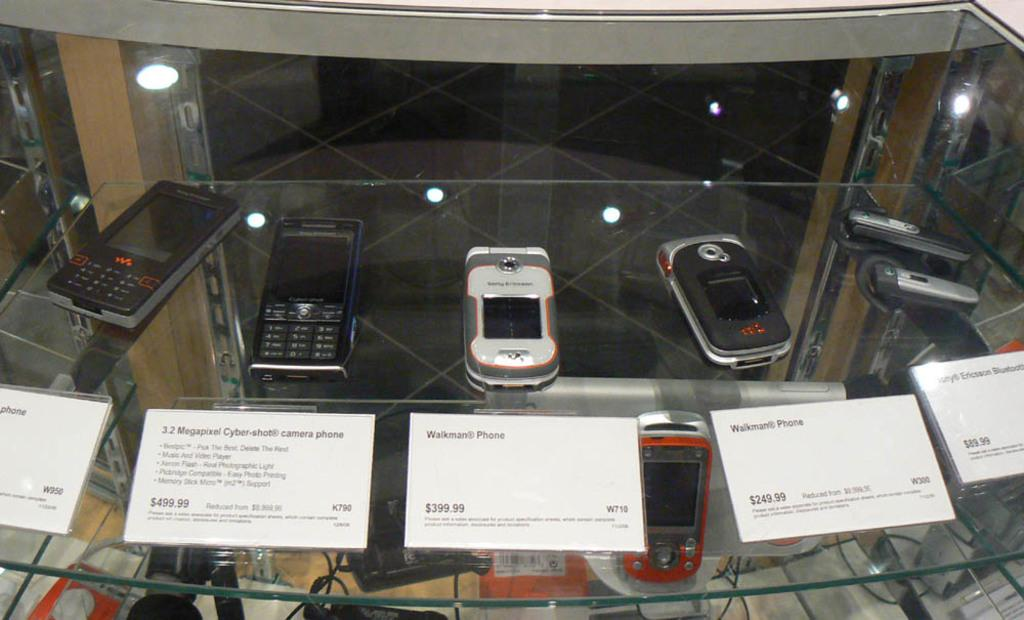<image>
Relay a brief, clear account of the picture shown. The cell phone display has a Walkman Phone selling for $399.99. 